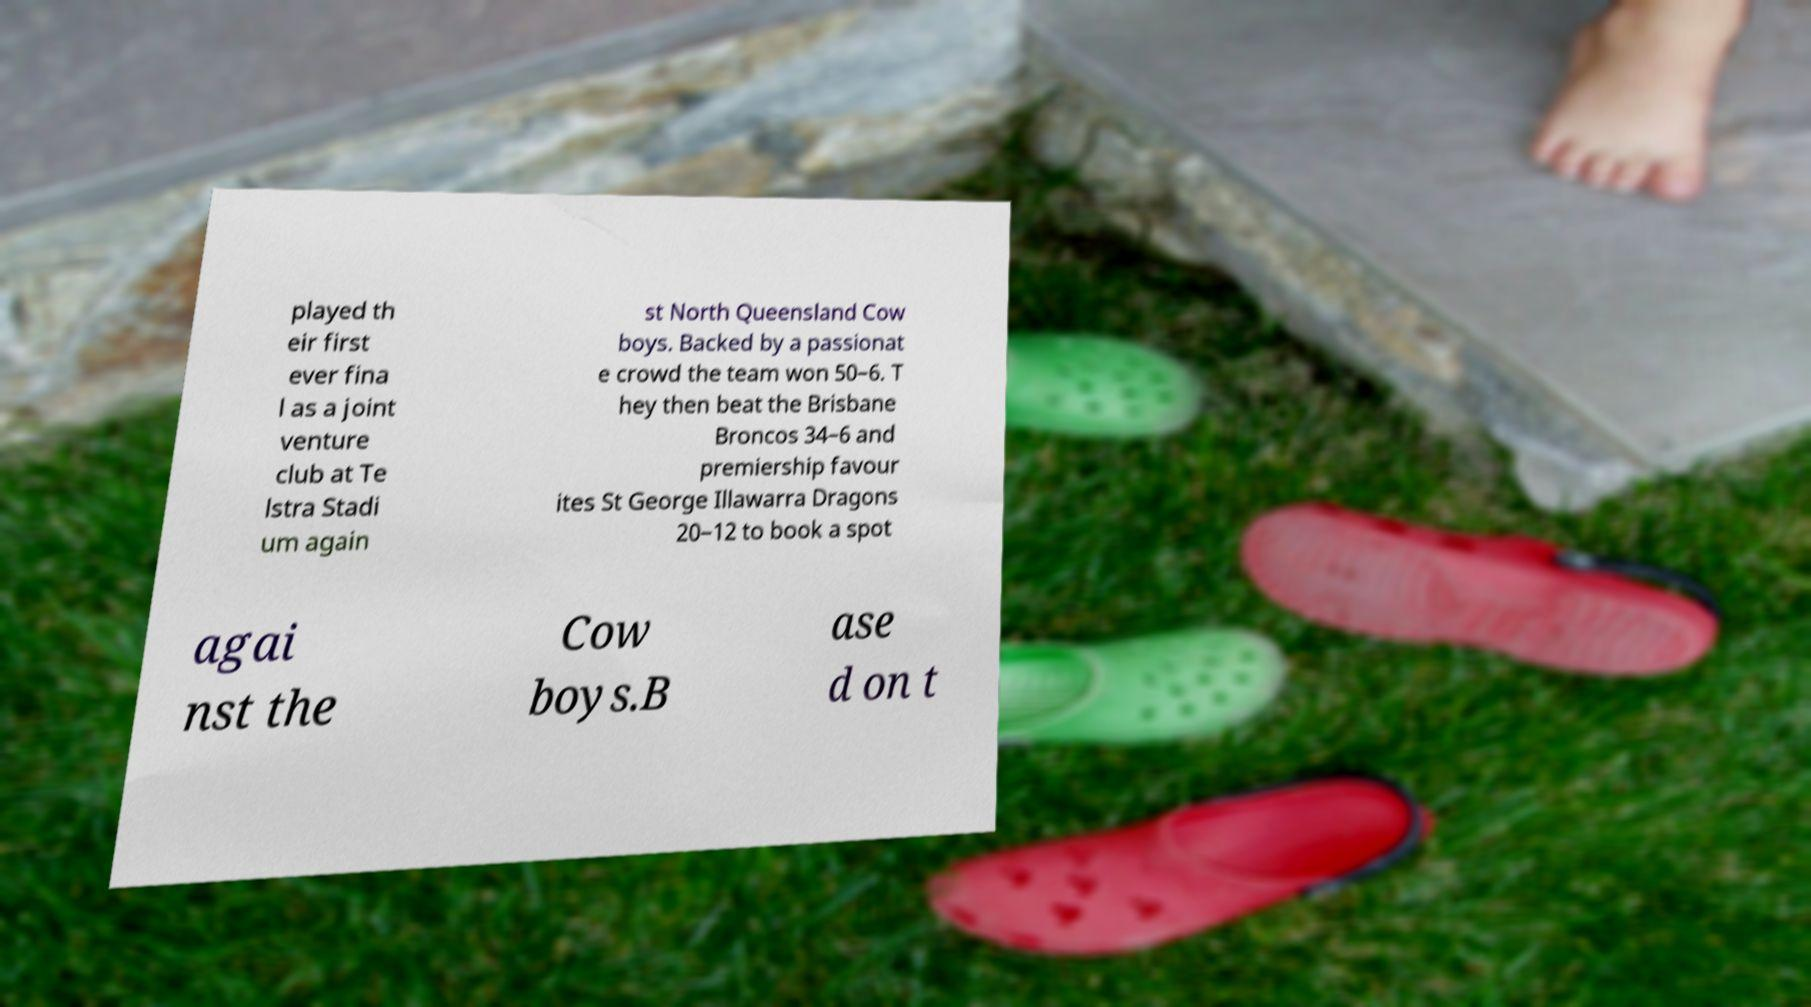There's text embedded in this image that I need extracted. Can you transcribe it verbatim? played th eir first ever fina l as a joint venture club at Te lstra Stadi um again st North Queensland Cow boys. Backed by a passionat e crowd the team won 50–6. T hey then beat the Brisbane Broncos 34–6 and premiership favour ites St George Illawarra Dragons 20–12 to book a spot agai nst the Cow boys.B ase d on t 